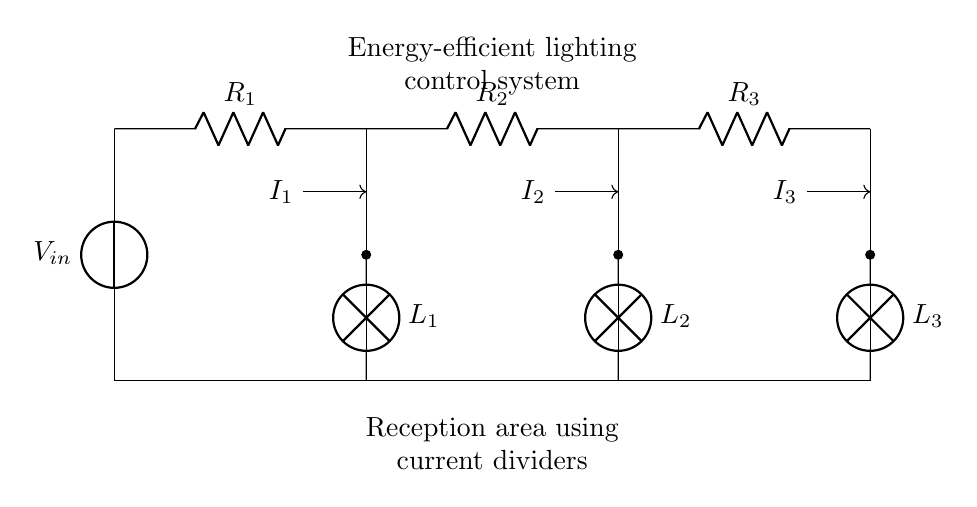What is the total number of resistors in this circuit? The circuit diagram displays three resistors labeled R1, R2, and R3. Counting them gives a total of three resistors.
Answer: three What kind of components are L1, L2, and L3? The components L1, L2, and L3 are identified as lamps in the circuit, which are typically used for lighting.
Answer: lamps What is the input voltage symbol in this circuit? The input voltage is represented by the symbol V_in, which sources the voltage to the entire circuit.
Answer: V_in Which resistor will have the highest current if they are equal? Since the current splits among the resistors and they are equal, the first resistor, R1, will have the highest current because it is directly connected to the input voltage.
Answer: R1 What is the relationship between the current through R1, R2, and R3? The current through each resistor is inversely proportional to its resistance value. For equal resistances, the currents will divide, leading to a specific ratio based on their values.
Answer: inverse proportionality How does the current divider rule apply here? The current divider rule states that the current divides among the parallel branches in inverse proportion to their resistances. Since R1, R2, and R3 are in parallel, the total current will split between them according to this rule.
Answer: it divides inversely to resistance What is the purpose of this circuit diagram in a reception area? The circuit diagram illustrates an energy-efficient lighting control system, which is essential for managing the lighting in a reception area to save energy while providing adequate illumination.
Answer: energy-efficient lighting management 